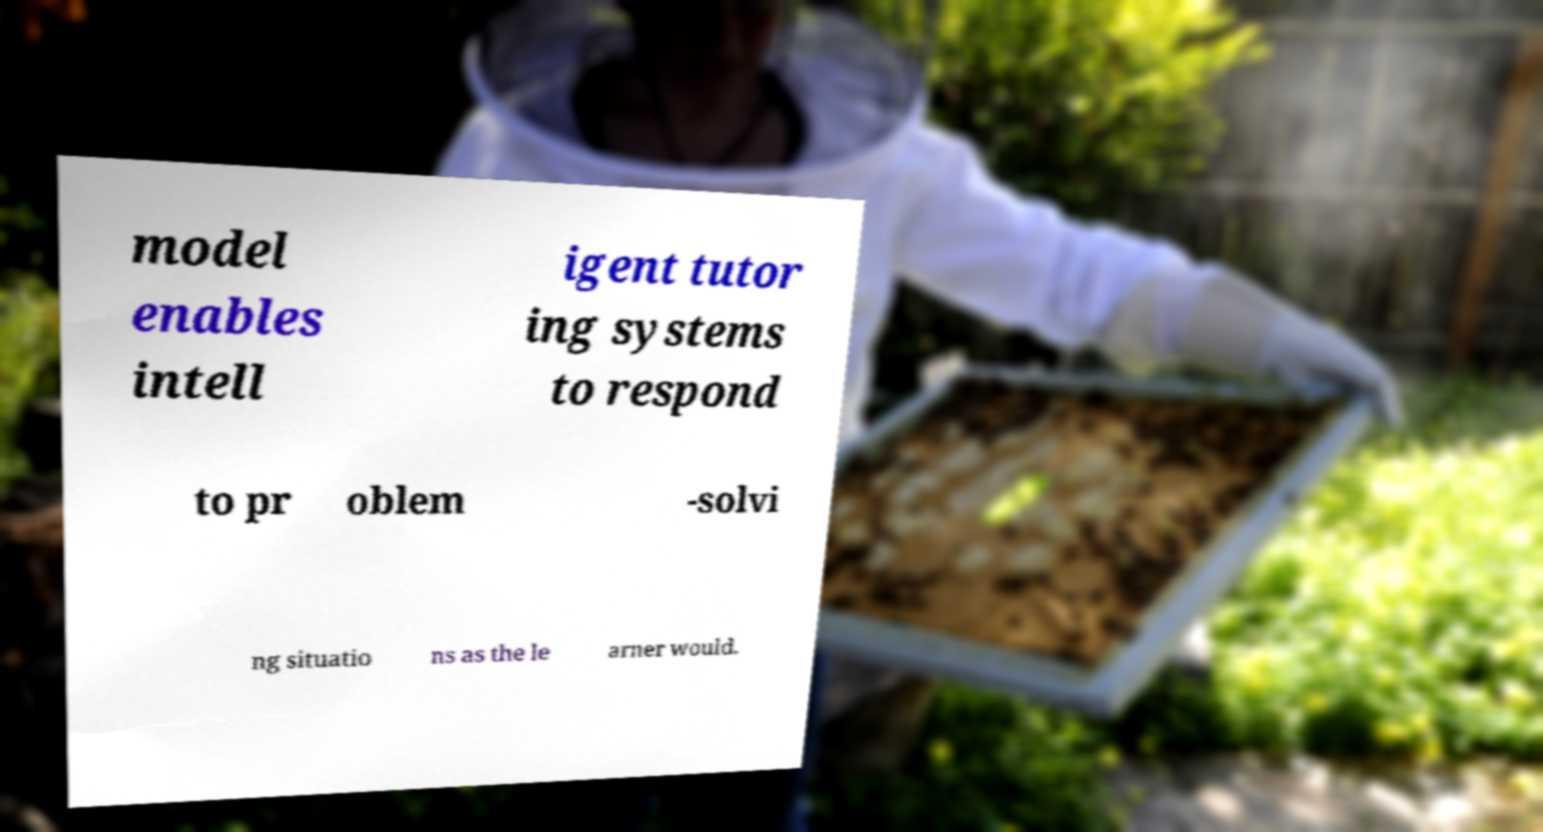Could you assist in decoding the text presented in this image and type it out clearly? model enables intell igent tutor ing systems to respond to pr oblem -solvi ng situatio ns as the le arner would. 